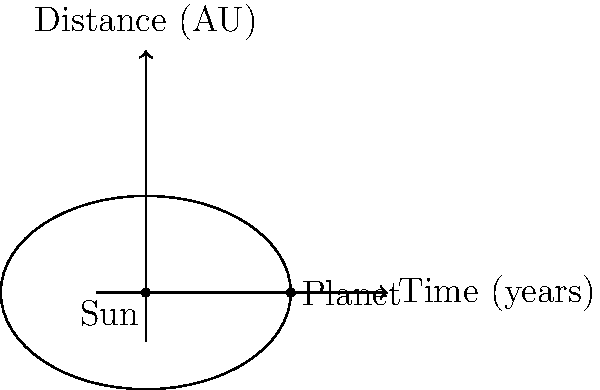As a historical curator of astronomical discoveries, you've come across data about a newly discovered exoplanet. The planet's orbit is elliptical with a semi-major axis of 3 AU. At aphelion, the planet is 4 AU from its star. Using Kepler's Third Law and trigonometric relationships, calculate the orbital period of this exoplanet in Earth years. (Assume the star has the same mass as our Sun) Let's approach this step-by-step:

1) First, we need to recall Kepler's Third Law:
   $$ T^2 = a^3 $$
   where $T$ is the orbital period in Earth years and $a$ is the semi-major axis in AU.

2) We're given that the semi-major axis $a = 3$ AU.

3) To find the orbital period, we simply need to substitute this into Kepler's Third Law:
   $$ T^2 = 3^3 = 27 $$

4) Taking the square root of both sides:
   $$ T = \sqrt{27} = 3\sqrt{3} \approx 5.2 $$

5) Therefore, the orbital period is approximately 5.2 Earth years.

Note: The trigonometric aspect of this problem isn't directly used in the calculation, but it's implicit in understanding the elliptical orbit. The relationship between the semi-major axis and the aphelion distance involves the eccentricity of the orbit, which can be calculated using trigonometric functions if needed.
Answer: 5.2 Earth years 